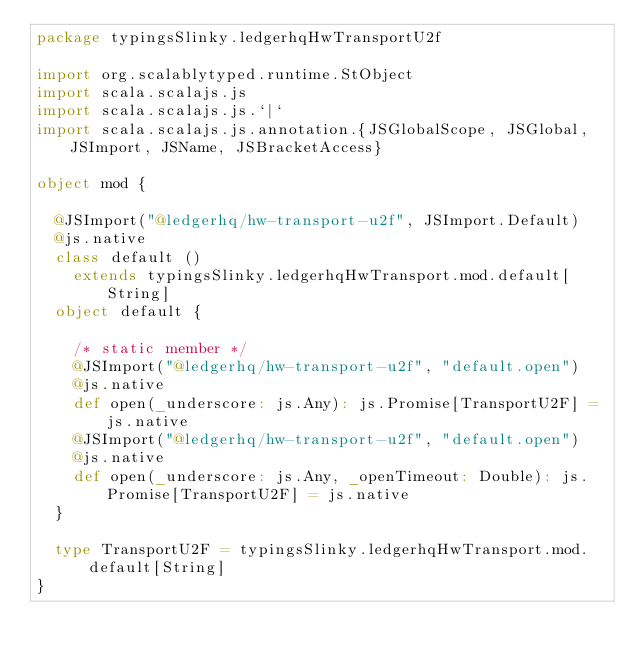<code> <loc_0><loc_0><loc_500><loc_500><_Scala_>package typingsSlinky.ledgerhqHwTransportU2f

import org.scalablytyped.runtime.StObject
import scala.scalajs.js
import scala.scalajs.js.`|`
import scala.scalajs.js.annotation.{JSGlobalScope, JSGlobal, JSImport, JSName, JSBracketAccess}

object mod {
  
  @JSImport("@ledgerhq/hw-transport-u2f", JSImport.Default)
  @js.native
  class default ()
    extends typingsSlinky.ledgerhqHwTransport.mod.default[String]
  object default {
    
    /* static member */
    @JSImport("@ledgerhq/hw-transport-u2f", "default.open")
    @js.native
    def open(_underscore: js.Any): js.Promise[TransportU2F] = js.native
    @JSImport("@ledgerhq/hw-transport-u2f", "default.open")
    @js.native
    def open(_underscore: js.Any, _openTimeout: Double): js.Promise[TransportU2F] = js.native
  }
  
  type TransportU2F = typingsSlinky.ledgerhqHwTransport.mod.default[String]
}
</code> 